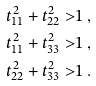<formula> <loc_0><loc_0><loc_500><loc_500>t _ { 1 1 } ^ { 2 } + t _ { 2 2 } ^ { 2 } > & 1 \ , \\ t _ { 1 1 } ^ { 2 } + t _ { 3 3 } ^ { 2 } > & 1 \ , \\ t _ { 2 2 } ^ { 2 } + t _ { 3 3 } ^ { 2 } > & 1 \ .</formula> 